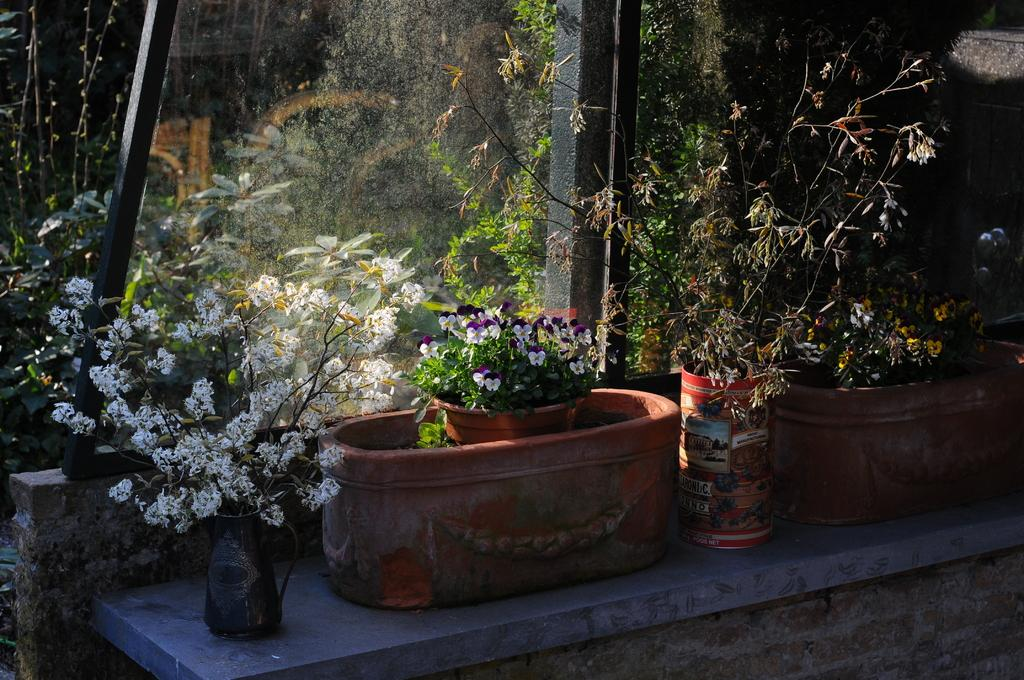What type of pots can be seen in the image? There are many plant pots and flower pots in the image. Where are the pots located? The pots are on a shelf. What is in front of the shelf? There is a glass window in front of the shelf. How many lines are drawn on the doll in the image? There is no doll present in the image, so it is not possible to determine how many lines are drawn on it. 